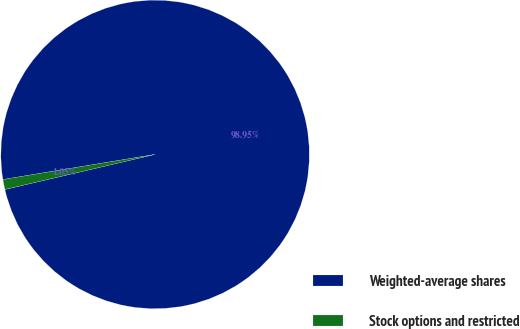<chart> <loc_0><loc_0><loc_500><loc_500><pie_chart><fcel>Weighted-average shares<fcel>Stock options and restricted<nl><fcel>98.95%<fcel>1.05%<nl></chart> 